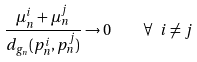<formula> <loc_0><loc_0><loc_500><loc_500>\frac { \mu _ { n } ^ { i } + \mu _ { n } ^ { j } } { d _ { g _ { n } } ( p _ { n } ^ { i } , p _ { n } ^ { j } ) } \to 0 \quad \forall \ i \not = j</formula> 